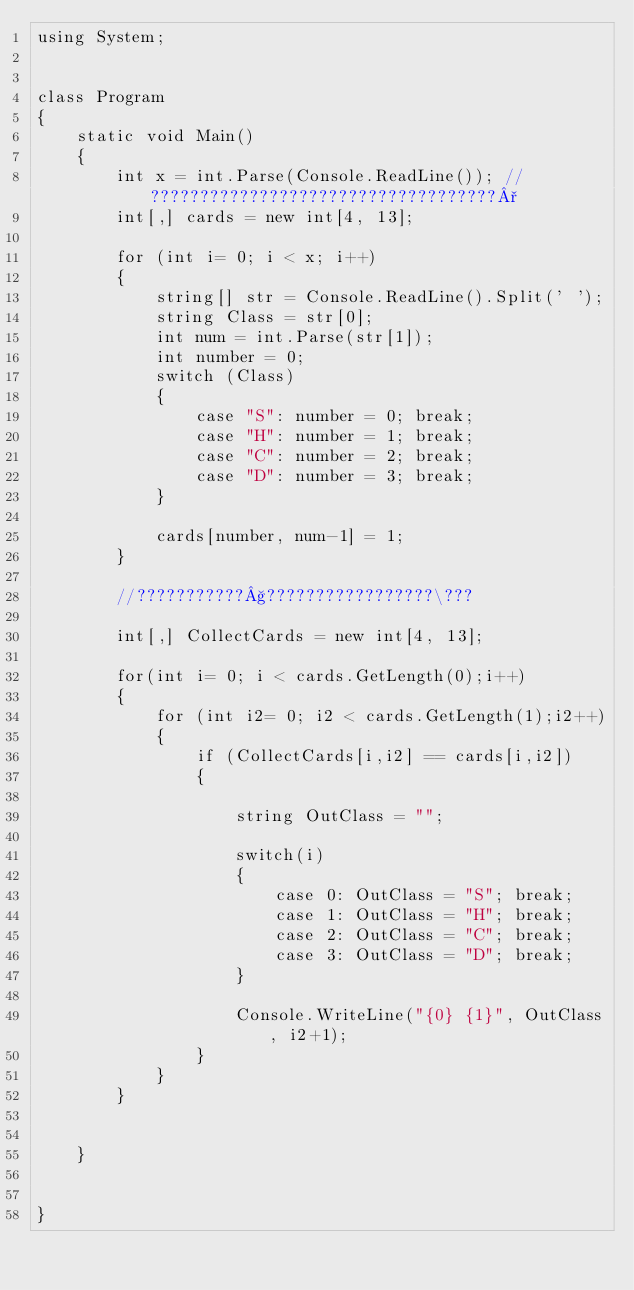<code> <loc_0><loc_0><loc_500><loc_500><_C#_>using System;


class Program
{
    static void Main()
    {
        int x = int.Parse(Console.ReadLine()); //???????????????????????????????????°
        int[,] cards = new int[4, 13];

        for (int i= 0; i < x; i++)
        {
            string[] str = Console.ReadLine().Split(' ');
            string Class = str[0];
            int num = int.Parse(str[1]);
            int number = 0;
            switch (Class)
            {
                case "S": number = 0; break;
                case "H": number = 1; break;
                case "C": number = 2; break;
                case "D": number = 3; break;
            }

            cards[number, num-1] = 1;
        }

        //???????????§?????????????????\???

        int[,] CollectCards = new int[4, 13];

        for(int i= 0; i < cards.GetLength(0);i++)
        {
            for (int i2= 0; i2 < cards.GetLength(1);i2++)
            {
                if (CollectCards[i,i2] == cards[i,i2])
                {
                    
                    string OutClass = "";

                    switch(i)
                    {
                        case 0: OutClass = "S"; break;
                        case 1: OutClass = "H"; break;
                        case 2: OutClass = "C"; break;
                        case 3: OutClass = "D"; break;
                    }

                    Console.WriteLine("{0} {1}", OutClass, i2+1);
                }
            }
        }
    

    }


}</code> 